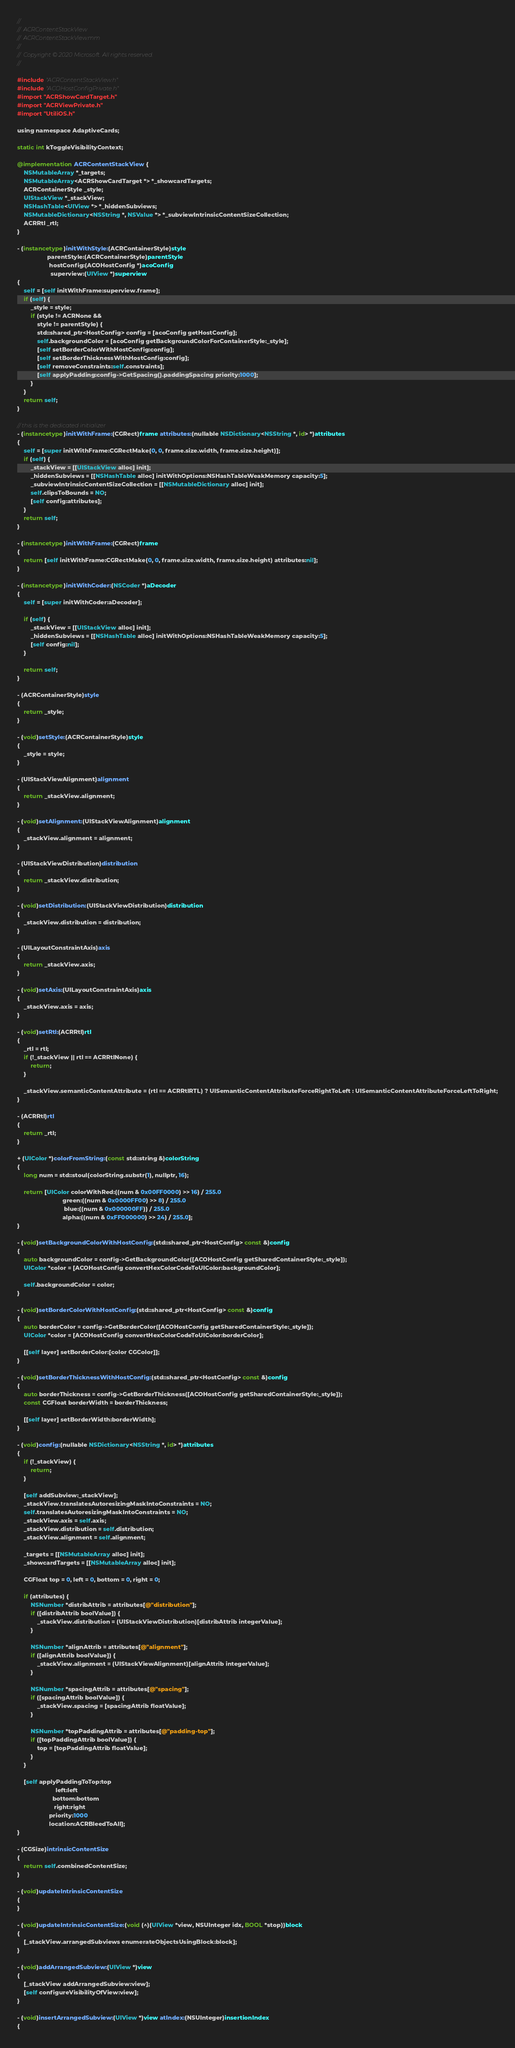<code> <loc_0><loc_0><loc_500><loc_500><_ObjectiveC_>//
//  ACRContentStackView
//  ACRContentStackView.mm
//
//  Copyright © 2020 Microsoft. All rights reserved.
//

#include "ACRContentStackView.h"
#include "ACOHostConfigPrivate.h"
#import "ACRShowCardTarget.h"
#import "ACRViewPrivate.h"
#import "UtiliOS.h"

using namespace AdaptiveCards;

static int kToggleVisibilityContext;

@implementation ACRContentStackView {
    NSMutableArray *_targets;
    NSMutableArray<ACRShowCardTarget *> *_showcardTargets;
    ACRContainerStyle _style;
    UIStackView *_stackView;
    NSHashTable<UIView *> *_hiddenSubviews;
    NSMutableDictionary<NSString *, NSValue *> *_subviewIntrinsicContentSizeCollection;
    ACRRtl _rtl;
}

- (instancetype)initWithStyle:(ACRContainerStyle)style
                  parentStyle:(ACRContainerStyle)parentStyle
                   hostConfig:(ACOHostConfig *)acoConfig
                    superview:(UIView *)superview
{
    self = [self initWithFrame:superview.frame];
    if (self) {
        _style = style;
        if (style != ACRNone &&
            style != parentStyle) {
            std::shared_ptr<HostConfig> config = [acoConfig getHostConfig];
            self.backgroundColor = [acoConfig getBackgroundColorForContainerStyle:_style];
            [self setBorderColorWithHostConfig:config];
            [self setBorderThicknessWithHostConfig:config];
            [self removeConstraints:self.constraints];
            [self applyPadding:config->GetSpacing().paddingSpacing priority:1000];
        }
    }
    return self;
}

// this is the dedicated initializer
- (instancetype)initWithFrame:(CGRect)frame attributes:(nullable NSDictionary<NSString *, id> *)attributes
{
    self = [super initWithFrame:CGRectMake(0, 0, frame.size.width, frame.size.height)];
    if (self) {
        _stackView = [[UIStackView alloc] init];
        _hiddenSubviews = [[NSHashTable alloc] initWithOptions:NSHashTableWeakMemory capacity:5];
        _subviewIntrinsicContentSizeCollection = [[NSMutableDictionary alloc] init];
        self.clipsToBounds = NO;
        [self config:attributes];
    }
    return self;
}

- (instancetype)initWithFrame:(CGRect)frame
{
    return [self initWithFrame:CGRectMake(0, 0, frame.size.width, frame.size.height) attributes:nil];
}

- (instancetype)initWithCoder:(NSCoder *)aDecoder
{
    self = [super initWithCoder:aDecoder];

    if (self) {
        _stackView = [[UIStackView alloc] init];
        _hiddenSubviews = [[NSHashTable alloc] initWithOptions:NSHashTableWeakMemory capacity:5];
        [self config:nil];
    }

    return self;
}

- (ACRContainerStyle)style
{
    return _style;
}

- (void)setStyle:(ACRContainerStyle)style
{
    _style = style;
}

- (UIStackViewAlignment)alignment
{
    return _stackView.alignment;
}

- (void)setAlignment:(UIStackViewAlignment)alignment
{
    _stackView.alignment = alignment;
}

- (UIStackViewDistribution)distribution
{
    return _stackView.distribution;
}

- (void)setDistribution:(UIStackViewDistribution)distribution
{
    _stackView.distribution = distribution;
}

- (UILayoutConstraintAxis)axis
{
    return _stackView.axis;
}

- (void)setAxis:(UILayoutConstraintAxis)axis
{
    _stackView.axis = axis;
}

- (void)setRtl:(ACRRtl)rtl
{
    _rtl = rtl;
    if (!_stackView || rtl == ACRRtlNone) {
        return;
    }

    _stackView.semanticContentAttribute = (rtl == ACRRtlRTL) ? UISemanticContentAttributeForceRightToLeft : UISemanticContentAttributeForceLeftToRight;
}

- (ACRRtl)rtl
{
    return _rtl;
}

+ (UIColor *)colorFromString:(const std::string &)colorString
{
    long num = std::stoul(colorString.substr(1), nullptr, 16);

    return [UIColor colorWithRed:((num & 0x00FF0000) >> 16) / 255.0
                           green:((num & 0x0000FF00) >> 8) / 255.0
                            blue:((num & 0x000000FF)) / 255.0
                           alpha:((num & 0xFF000000) >> 24) / 255.0];
}

- (void)setBackgroundColorWithHostConfig:(std::shared_ptr<HostConfig> const &)config
{
    auto backgroundColor = config->GetBackgroundColor([ACOHostConfig getSharedContainerStyle:_style]);
    UIColor *color = [ACOHostConfig convertHexColorCodeToUIColor:backgroundColor];

    self.backgroundColor = color;
}

- (void)setBorderColorWithHostConfig:(std::shared_ptr<HostConfig> const &)config
{
    auto borderColor = config->GetBorderColor([ACOHostConfig getSharedContainerStyle:_style]);
    UIColor *color = [ACOHostConfig convertHexColorCodeToUIColor:borderColor];

    [[self layer] setBorderColor:[color CGColor]];
}

- (void)setBorderThicknessWithHostConfig:(std::shared_ptr<HostConfig> const &)config
{
    auto borderThickness = config->GetBorderThickness([ACOHostConfig getSharedContainerStyle:_style]);
    const CGFloat borderWidth = borderThickness;

    [[self layer] setBorderWidth:borderWidth];
}

- (void)config:(nullable NSDictionary<NSString *, id> *)attributes
{
    if (!_stackView) {
        return;
    }

    [self addSubview:_stackView];
    _stackView.translatesAutoresizingMaskIntoConstraints = NO;
    self.translatesAutoresizingMaskIntoConstraints = NO;
    _stackView.axis = self.axis;
    _stackView.distribution = self.distribution;
    _stackView.alignment = self.alignment;

    _targets = [[NSMutableArray alloc] init];
    _showcardTargets = [[NSMutableArray alloc] init];

    CGFloat top = 0, left = 0, bottom = 0, right = 0;

    if (attributes) {
        NSNumber *distribAttrib = attributes[@"distribution"];
        if ([distribAttrib boolValue]) {
            _stackView.distribution = (UIStackViewDistribution)[distribAttrib integerValue];
        }

        NSNumber *alignAttrib = attributes[@"alignment"];
        if ([alignAttrib boolValue]) {
            _stackView.alignment = (UIStackViewAlignment)[alignAttrib integerValue];
        }

        NSNumber *spacingAttrib = attributes[@"spacing"];
        if ([spacingAttrib boolValue]) {
            _stackView.spacing = [spacingAttrib floatValue];
        }

        NSNumber *topPaddingAttrib = attributes[@"padding-top"];
        if ([topPaddingAttrib boolValue]) {
            top = [topPaddingAttrib floatValue];
        }
    }

    [self applyPaddingToTop:top
                       left:left
                     bottom:bottom
                      right:right
                   priority:1000
                   location:ACRBleedToAll];
}

- (CGSize)intrinsicContentSize
{
    return self.combinedContentSize;
}

- (void)updateIntrinsicContentSize
{
}

- (void)updateIntrinsicContentSize:(void (^)(UIView *view, NSUInteger idx, BOOL *stop))block
{
    [_stackView.arrangedSubviews enumerateObjectsUsingBlock:block];
}

- (void)addArrangedSubview:(UIView *)view
{
    [_stackView addArrangedSubview:view];
    [self configureVisibilityOfView:view];
}

- (void)insertArrangedSubview:(UIView *)view atIndex:(NSUInteger)insertionIndex
{</code> 